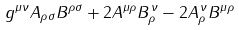Convert formula to latex. <formula><loc_0><loc_0><loc_500><loc_500>g ^ { \mu \nu } A _ { \rho \sigma } B ^ { \rho \sigma } + 2 A ^ { \mu \rho } B _ { \rho } ^ { \, \nu } - 2 A _ { \rho } ^ { \, \nu } B ^ { \mu \rho }</formula> 